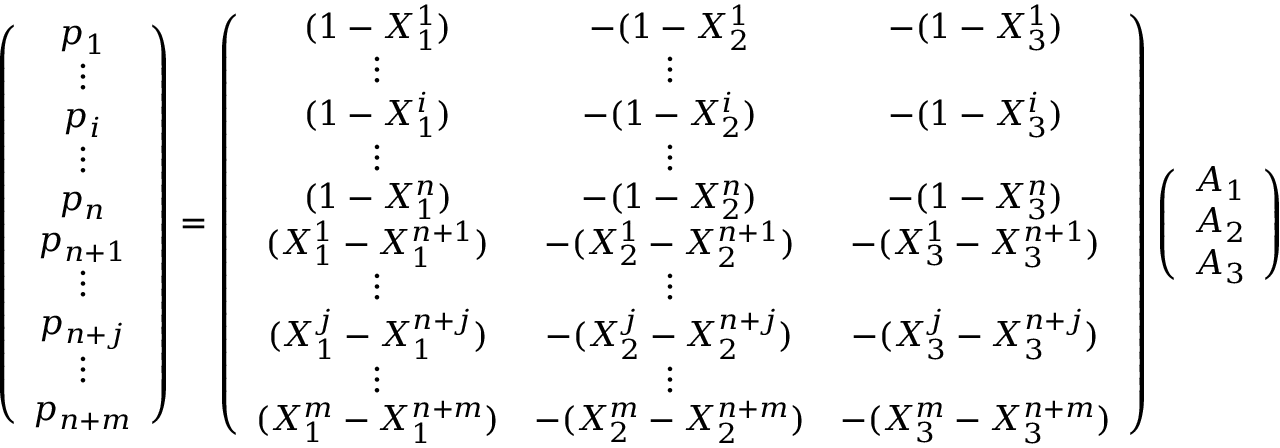Convert formula to latex. <formula><loc_0><loc_0><loc_500><loc_500>\left ( \begin{array} { c } { p _ { 1 } } \\ { \vdots } \\ { p _ { i } } \\ { \vdots } \\ { p _ { n } } \\ { p _ { n + 1 } } \\ { \vdots } \\ { p _ { n + j } } \\ { \vdots } \\ { p _ { n + m } } \end{array} \right ) = \left ( \begin{array} { c c c } { ( 1 - X _ { 1 } ^ { 1 } ) } & { - ( 1 - X _ { 2 } ^ { 1 } } & { - ( 1 - X _ { 3 } ^ { 1 } ) } \\ { \vdots } & { \vdots } \\ { ( 1 - X _ { 1 } ^ { i } ) } & { - ( 1 - X _ { 2 } ^ { i } ) } & { - ( 1 - X _ { 3 } ^ { i } ) } \\ { \vdots } & { \vdots } \\ { ( 1 - X _ { 1 } ^ { n } ) } & { - ( 1 - X _ { 2 } ^ { n } ) } & { - ( 1 - X _ { 3 } ^ { n } ) } \\ { ( X _ { 1 } ^ { 1 } - X _ { 1 } ^ { n + 1 } ) } & { - ( X _ { 2 } ^ { 1 } - X _ { 2 } ^ { n + 1 } ) } & { - ( X _ { 3 } ^ { 1 } - X _ { 3 } ^ { n + 1 } ) } \\ { \vdots } & { \vdots } \\ { ( X _ { 1 } ^ { j } - X _ { 1 } ^ { n + j } ) } & { - ( X _ { 2 } ^ { j } - X _ { 2 } ^ { n + j } ) } & { - ( X _ { 3 } ^ { j } - X _ { 3 } ^ { n + j } ) } \\ { \vdots } & { \vdots } \\ { ( X _ { 1 } ^ { m } - X _ { 1 } ^ { n + m } ) } & { - ( X _ { 2 } ^ { m } - X _ { 2 } ^ { n + m } ) } & { - ( X _ { 3 } ^ { m } - X _ { 3 } ^ { n + m } ) } \end{array} \right ) \left ( \begin{array} { c } { A _ { 1 } } \\ { A _ { 2 } } \\ { A _ { 3 } } \end{array} \right )</formula> 